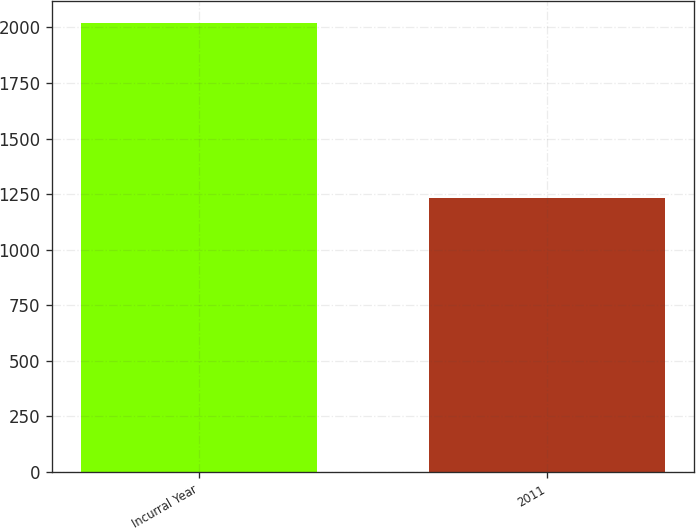Convert chart to OTSL. <chart><loc_0><loc_0><loc_500><loc_500><bar_chart><fcel>Incurral Year<fcel>2011<nl><fcel>2018<fcel>1231<nl></chart> 